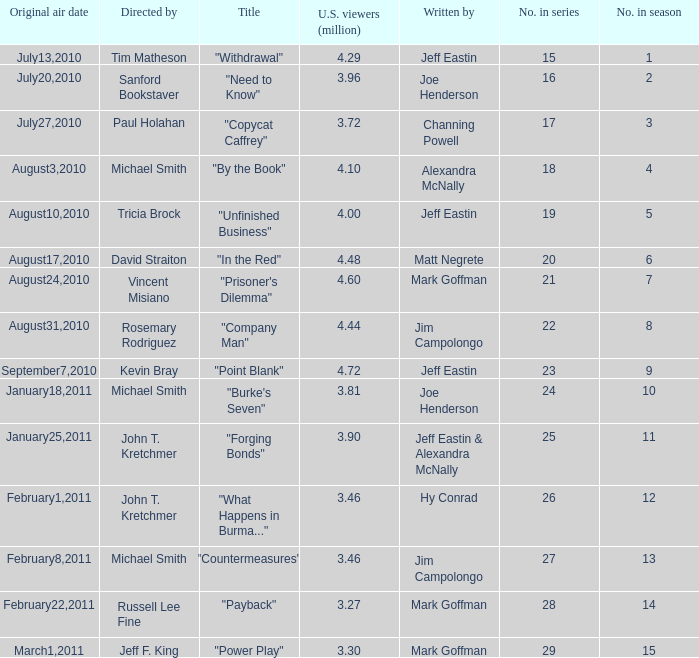How many episodes in the season had 3.81 million US viewers? 1.0. 